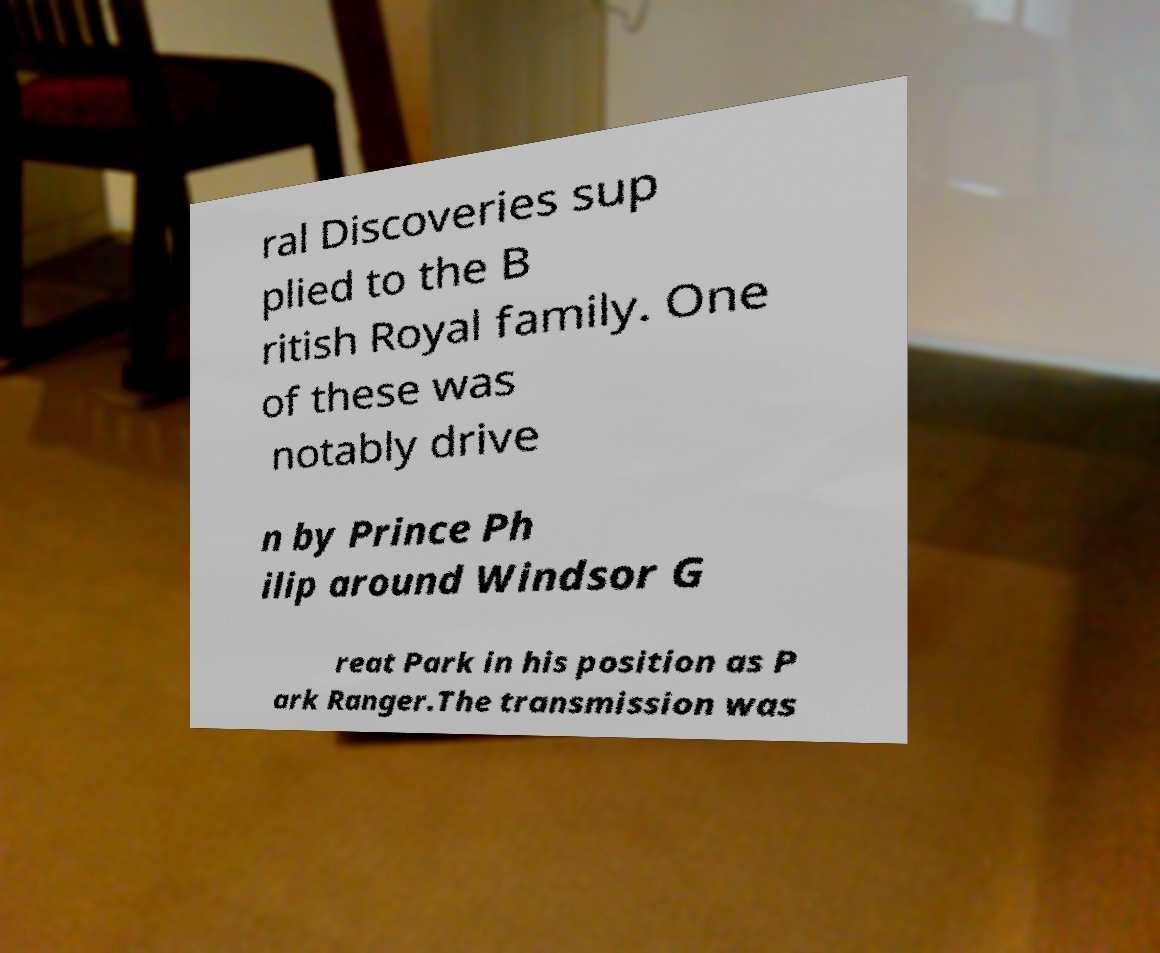Can you accurately transcribe the text from the provided image for me? ral Discoveries sup plied to the B ritish Royal family. One of these was notably drive n by Prince Ph ilip around Windsor G reat Park in his position as P ark Ranger.The transmission was 